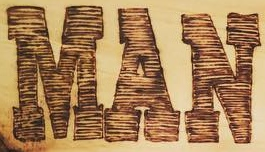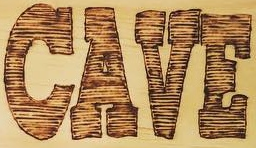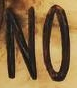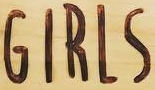Identify the words shown in these images in order, separated by a semicolon. MAN; CAVE; NO; GIRLS 